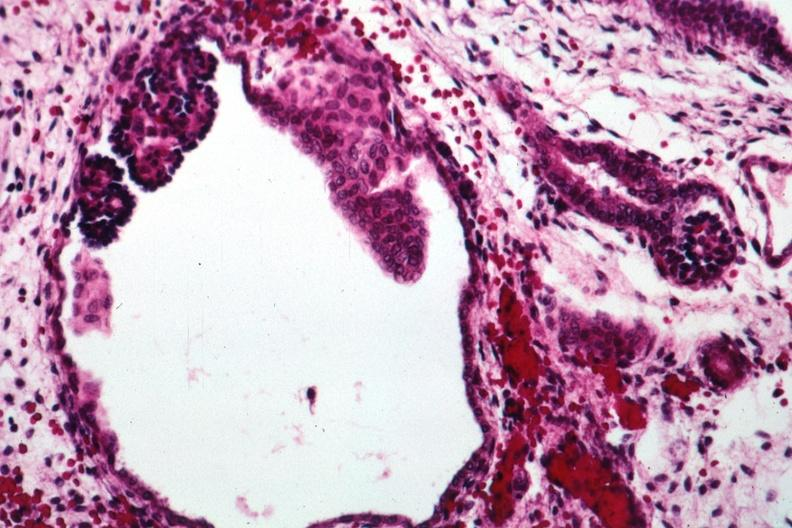where is this?
Answer the question using a single word or phrase. Urinary 